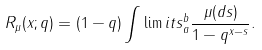<formula> <loc_0><loc_0><loc_500><loc_500>R _ { \mu } ( x ; q ) = ( 1 - q ) \int \lim i t s _ { a } ^ { b } \frac { \mu ( d s ) } { 1 - q ^ { x - s } } .</formula> 